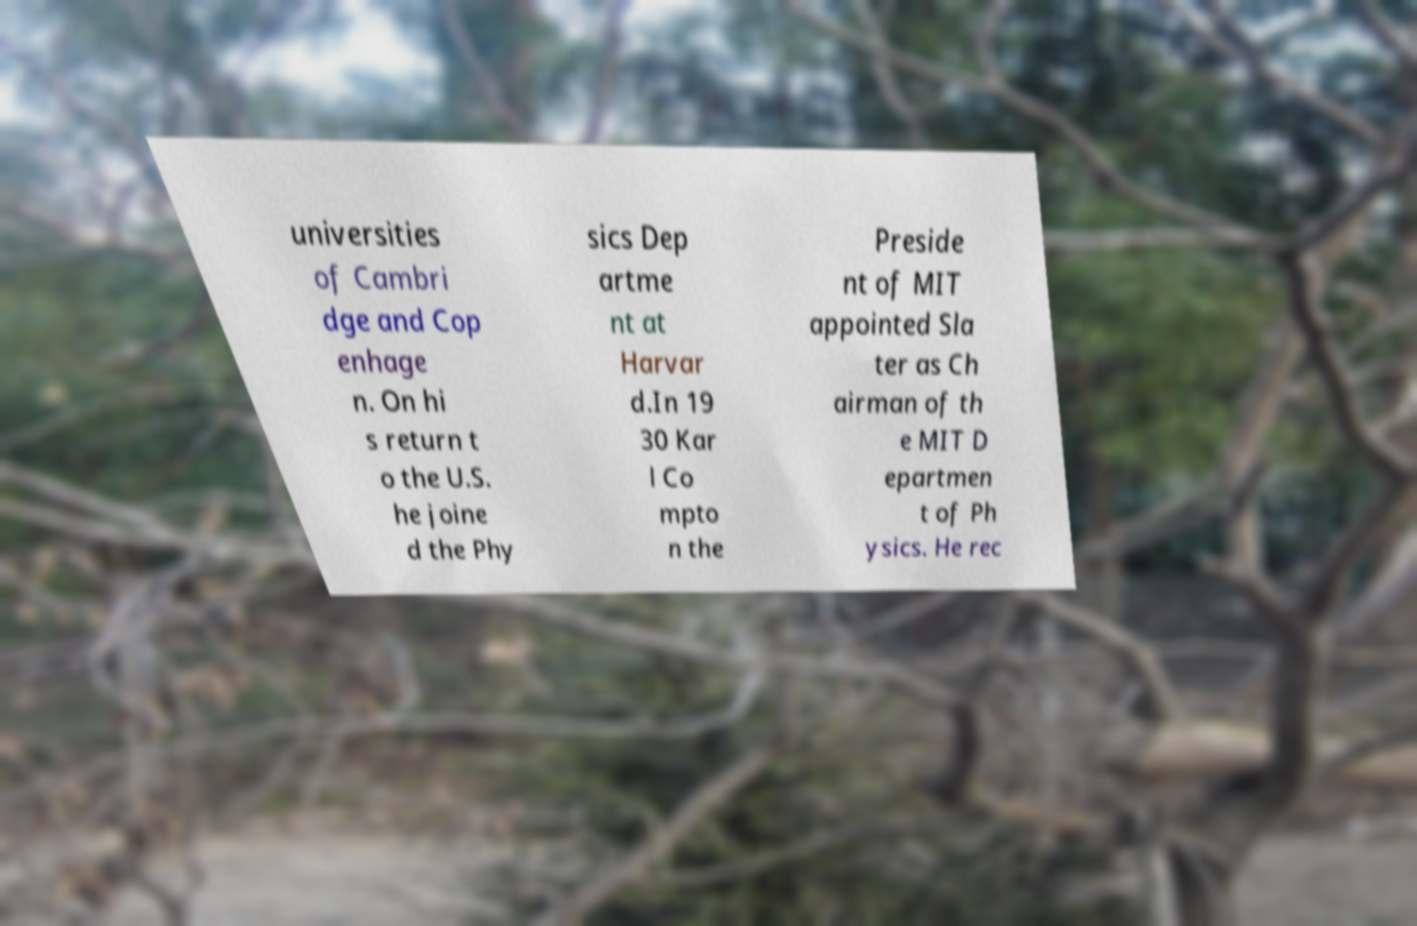Please identify and transcribe the text found in this image. universities of Cambri dge and Cop enhage n. On hi s return t o the U.S. he joine d the Phy sics Dep artme nt at Harvar d.In 19 30 Kar l Co mpto n the Preside nt of MIT appointed Sla ter as Ch airman of th e MIT D epartmen t of Ph ysics. He rec 